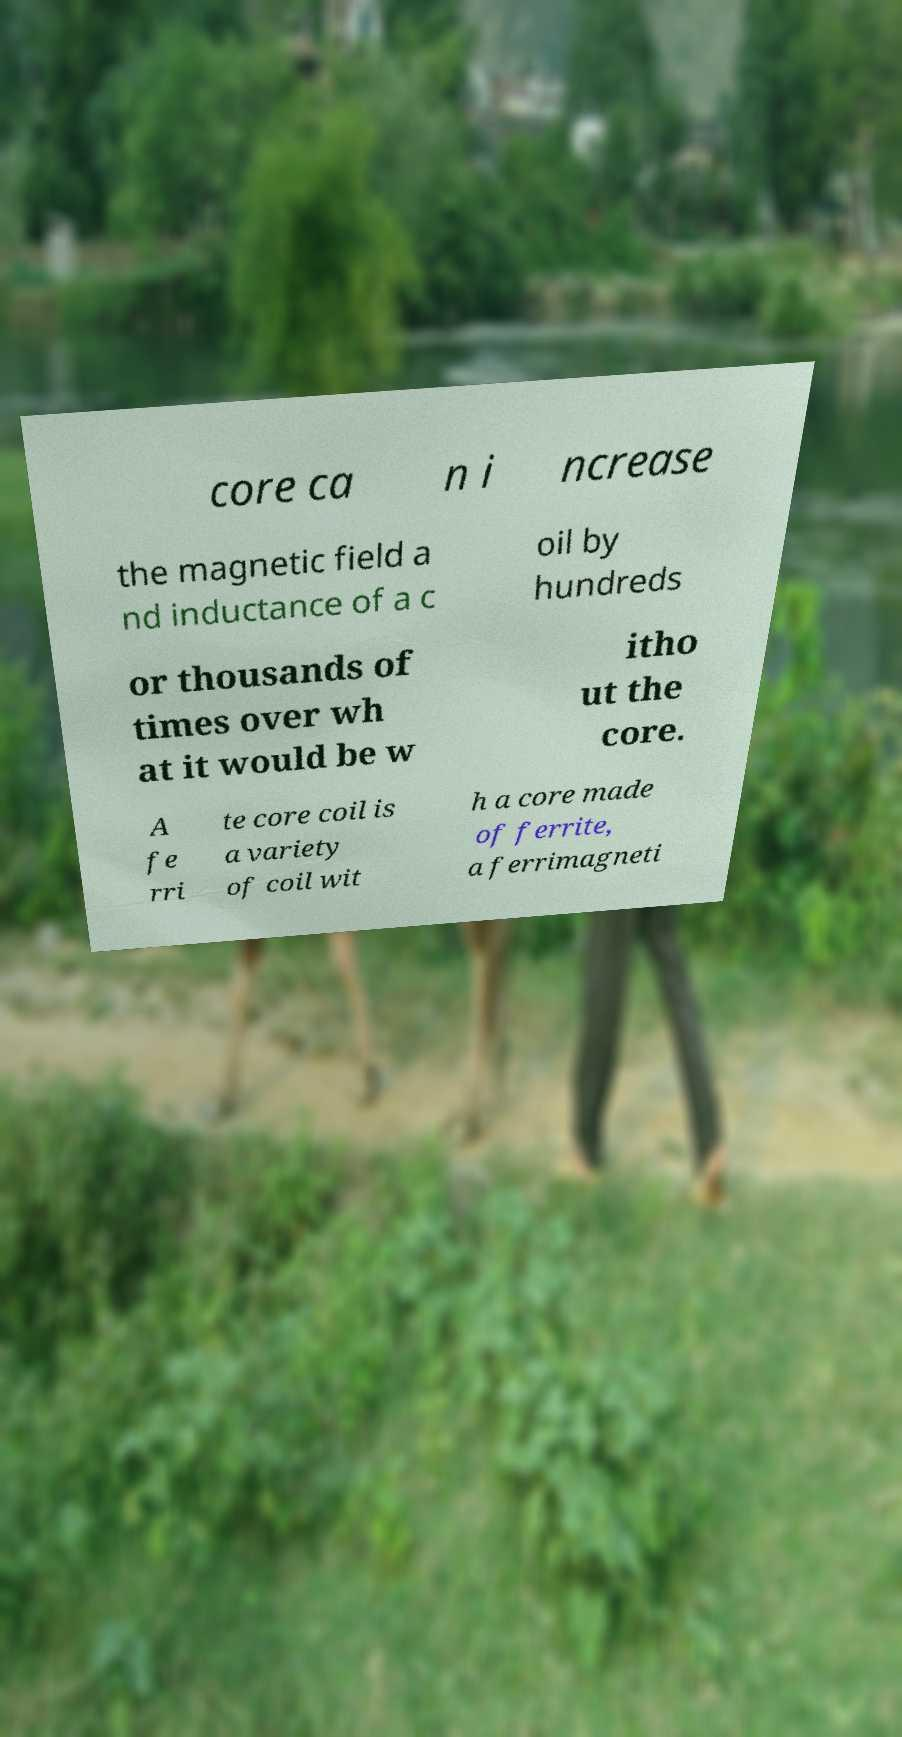Please read and relay the text visible in this image. What does it say? core ca n i ncrease the magnetic field a nd inductance of a c oil by hundreds or thousands of times over wh at it would be w itho ut the core. A fe rri te core coil is a variety of coil wit h a core made of ferrite, a ferrimagneti 